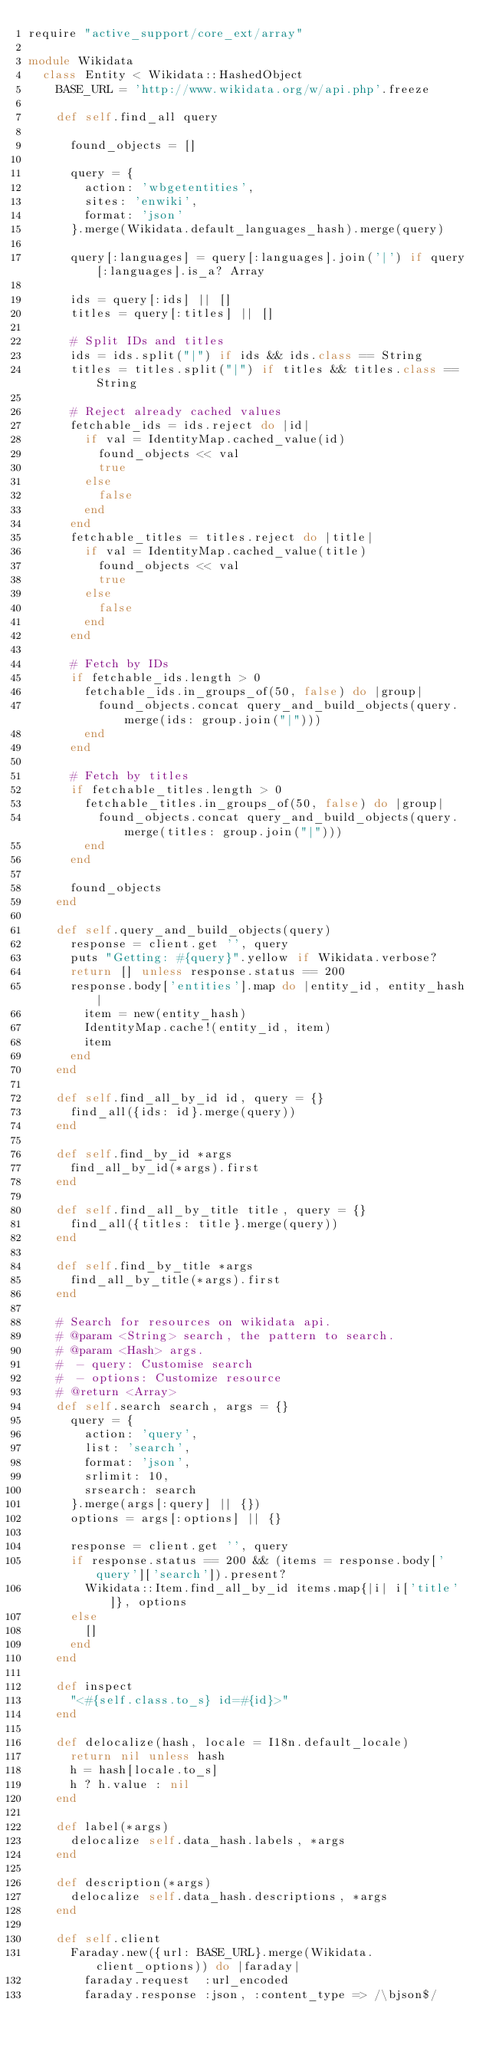Convert code to text. <code><loc_0><loc_0><loc_500><loc_500><_Ruby_>require "active_support/core_ext/array"

module Wikidata
  class Entity < Wikidata::HashedObject
    BASE_URL = 'http://www.wikidata.org/w/api.php'.freeze

    def self.find_all query

      found_objects = []

      query = {
        action: 'wbgetentities',
        sites: 'enwiki',
        format: 'json'
      }.merge(Wikidata.default_languages_hash).merge(query)

      query[:languages] = query[:languages].join('|') if query[:languages].is_a? Array

      ids = query[:ids] || []
      titles = query[:titles] || []

      # Split IDs and titles
      ids = ids.split("|") if ids && ids.class == String
      titles = titles.split("|") if titles && titles.class == String

      # Reject already cached values
      fetchable_ids = ids.reject do |id|
        if val = IdentityMap.cached_value(id)
          found_objects << val
          true
        else
          false
        end
      end
      fetchable_titles = titles.reject do |title|
        if val = IdentityMap.cached_value(title)
          found_objects << val
          true
        else
          false
        end
      end

      # Fetch by IDs
      if fetchable_ids.length > 0
        fetchable_ids.in_groups_of(50, false) do |group|
          found_objects.concat query_and_build_objects(query.merge(ids: group.join("|")))
        end
      end

      # Fetch by titles
      if fetchable_titles.length > 0
        fetchable_titles.in_groups_of(50, false) do |group|
          found_objects.concat query_and_build_objects(query.merge(titles: group.join("|")))
        end
      end

      found_objects
    end

    def self.query_and_build_objects(query)
      response = client.get '', query
      puts "Getting: #{query}".yellow if Wikidata.verbose?
      return [] unless response.status == 200
      response.body['entities'].map do |entity_id, entity_hash|
        item = new(entity_hash)
        IdentityMap.cache!(entity_id, item)
        item
      end
    end

    def self.find_all_by_id id, query = {}
      find_all({ids: id}.merge(query))
    end

    def self.find_by_id *args
      find_all_by_id(*args).first
    end

    def self.find_all_by_title title, query = {}
      find_all({titles: title}.merge(query))
    end

    def self.find_by_title *args
      find_all_by_title(*args).first
    end

    # Search for resources on wikidata api.
    # @param <String> search, the pattern to search.
    # @param <Hash> args.
    #  - query: Customise search
    #  - options: Customize resource
    # @return <Array>
    def self.search search, args = {}
      query = {
        action: 'query',
        list: 'search',
        format: 'json',
        srlimit: 10,
        srsearch: search
      }.merge(args[:query] || {})
      options = args[:options] || {}

      response = client.get '', query
      if response.status == 200 && (items = response.body['query']['search']).present?
        Wikidata::Item.find_all_by_id items.map{|i| i['title']}, options
      else
        []
      end
    end

    def inspect
      "<#{self.class.to_s} id=#{id}>"
    end

    def delocalize(hash, locale = I18n.default_locale)
      return nil unless hash
      h = hash[locale.to_s]
      h ? h.value : nil
    end

    def label(*args)
      delocalize self.data_hash.labels, *args
    end

    def description(*args)
      delocalize self.data_hash.descriptions, *args
    end

    def self.client
      Faraday.new({url: BASE_URL}.merge(Wikidata.client_options)) do |faraday|
        faraday.request  :url_encoded
        faraday.response :json, :content_type => /\bjson$/</code> 